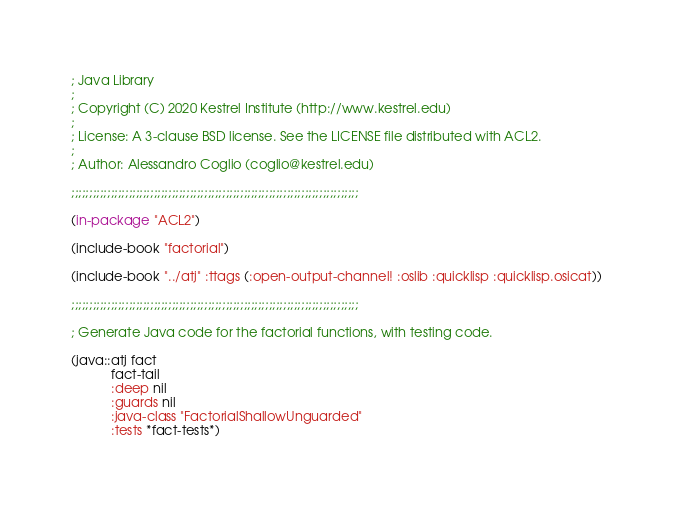Convert code to text. <code><loc_0><loc_0><loc_500><loc_500><_Lisp_>; Java Library
;
; Copyright (C) 2020 Kestrel Institute (http://www.kestrel.edu)
;
; License: A 3-clause BSD license. See the LICENSE file distributed with ACL2.
;
; Author: Alessandro Coglio (coglio@kestrel.edu)

;;;;;;;;;;;;;;;;;;;;;;;;;;;;;;;;;;;;;;;;;;;;;;;;;;;;;;;;;;;;;;;;;;;;;;;;;;;;;;;;

(in-package "ACL2")

(include-book "factorial")

(include-book "../atj" :ttags (:open-output-channel! :oslib :quicklisp :quicklisp.osicat))

;;;;;;;;;;;;;;;;;;;;;;;;;;;;;;;;;;;;;;;;;;;;;;;;;;;;;;;;;;;;;;;;;;;;;;;;;;;;;;;;

; Generate Java code for the factorial functions, with testing code.

(java::atj fact
           fact-tail
           :deep nil
           :guards nil
           :java-class "FactorialShallowUnguarded"
           :tests *fact-tests*)
</code> 